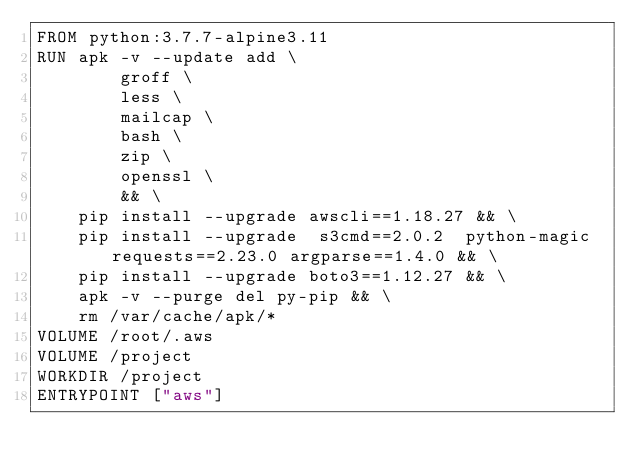<code> <loc_0><loc_0><loc_500><loc_500><_Dockerfile_>FROM python:3.7.7-alpine3.11 
RUN apk -v --update add \
        groff \
        less \
        mailcap \
        bash \
        zip \
        openssl \
        && \
    pip install --upgrade awscli==1.18.27 && \
    pip install --upgrade  s3cmd==2.0.2  python-magic requests==2.23.0 argparse==1.4.0 && \
    pip install --upgrade boto3==1.12.27 && \
    apk -v --purge del py-pip && \
    rm /var/cache/apk/*
VOLUME /root/.aws
VOLUME /project
WORKDIR /project
ENTRYPOINT ["aws"]
</code> 